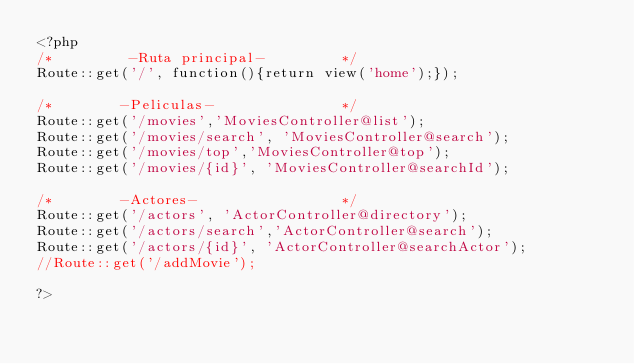<code> <loc_0><loc_0><loc_500><loc_500><_PHP_><?php
/*         -Ruta principal-         */
Route::get('/', function(){return view('home');});

/*        -Peliculas-               */
Route::get('/movies','MoviesController@list');
Route::get('/movies/search', 'MoviesController@search');
Route::get('/movies/top','MoviesController@top');
Route::get('/movies/{id}', 'MoviesController@searchId');

/*        -Actores-                 */
Route::get('/actors', 'ActorController@directory');
Route::get('/actors/search','ActorController@search');
Route::get('/actors/{id}', 'ActorController@searchActor');
//Route::get('/addMovie');

?></code> 